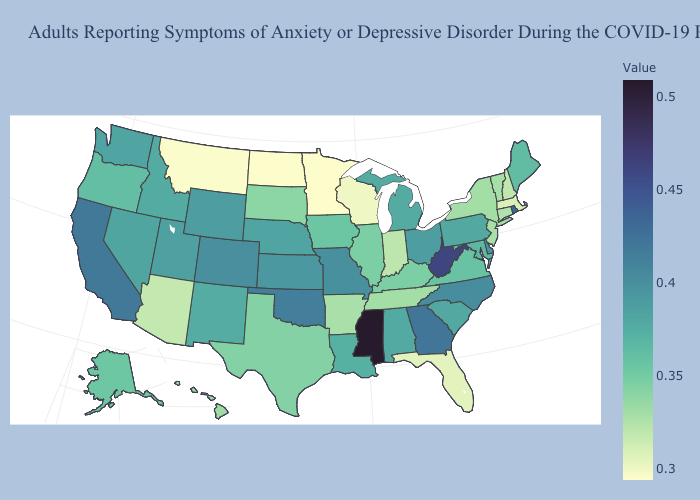Does Minnesota have the lowest value in the USA?
Give a very brief answer. Yes. Is the legend a continuous bar?
Keep it brief. Yes. Does Virginia have the lowest value in the South?
Short answer required. No. Which states hav the highest value in the MidWest?
Write a very short answer. Missouri. 